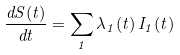<formula> <loc_0><loc_0><loc_500><loc_500>\frac { d S ( t ) } { d t } = \sum _ { 1 } \lambda _ { 1 } ( t ) \, I _ { 1 } ( t )</formula> 